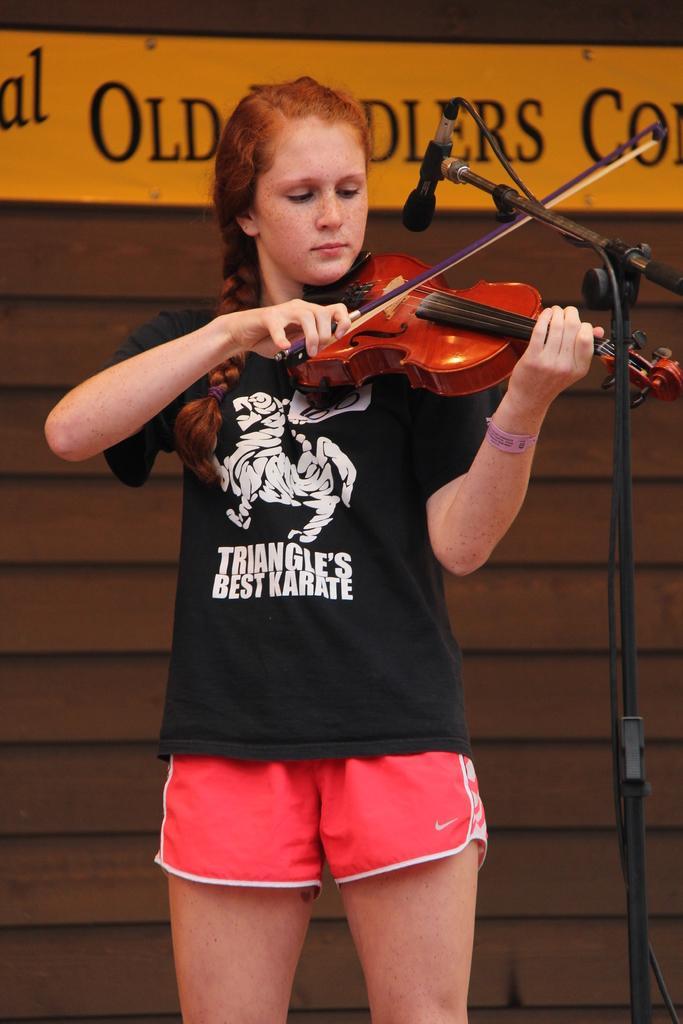Describe this image in one or two sentences. This image is clicked in a musical concert. There is a banner on the top and there is a girl standing in the middle. A mike is in front of her. She is playing violin, she is wearing black color t-shirt and pink color short. 